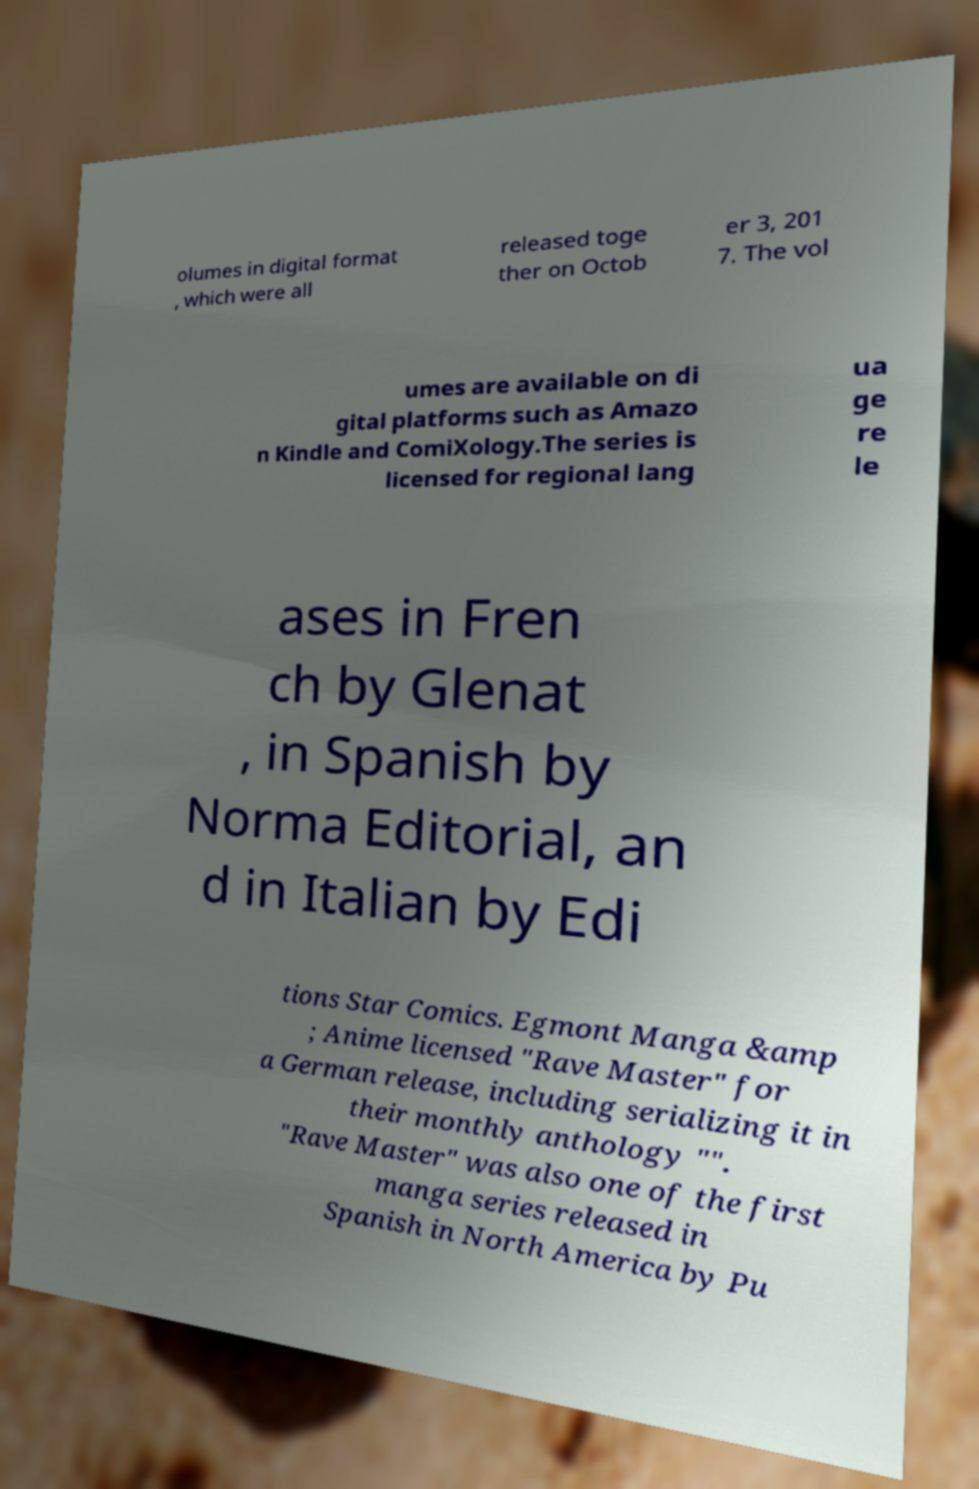Could you extract and type out the text from this image? olumes in digital format , which were all released toge ther on Octob er 3, 201 7. The vol umes are available on di gital platforms such as Amazo n Kindle and ComiXology.The series is licensed for regional lang ua ge re le ases in Fren ch by Glenat , in Spanish by Norma Editorial, an d in Italian by Edi tions Star Comics. Egmont Manga &amp ; Anime licensed "Rave Master" for a German release, including serializing it in their monthly anthology "". "Rave Master" was also one of the first manga series released in Spanish in North America by Pu 